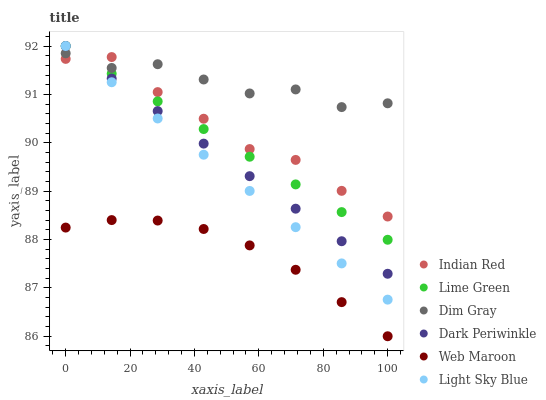Does Web Maroon have the minimum area under the curve?
Answer yes or no. Yes. Does Dim Gray have the maximum area under the curve?
Answer yes or no. Yes. Does Light Sky Blue have the minimum area under the curve?
Answer yes or no. No. Does Light Sky Blue have the maximum area under the curve?
Answer yes or no. No. Is Lime Green the smoothest?
Answer yes or no. Yes. Is Dim Gray the roughest?
Answer yes or no. Yes. Is Web Maroon the smoothest?
Answer yes or no. No. Is Web Maroon the roughest?
Answer yes or no. No. Does Web Maroon have the lowest value?
Answer yes or no. Yes. Does Light Sky Blue have the lowest value?
Answer yes or no. No. Does Dark Periwinkle have the highest value?
Answer yes or no. Yes. Does Web Maroon have the highest value?
Answer yes or no. No. Is Web Maroon less than Lime Green?
Answer yes or no. Yes. Is Dim Gray greater than Web Maroon?
Answer yes or no. Yes. Does Dark Periwinkle intersect Indian Red?
Answer yes or no. Yes. Is Dark Periwinkle less than Indian Red?
Answer yes or no. No. Is Dark Periwinkle greater than Indian Red?
Answer yes or no. No. Does Web Maroon intersect Lime Green?
Answer yes or no. No. 